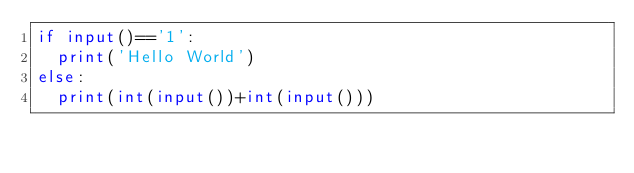<code> <loc_0><loc_0><loc_500><loc_500><_Python_>if input()=='1':
  print('Hello World')
else:
  print(int(input())+int(input()))
</code> 